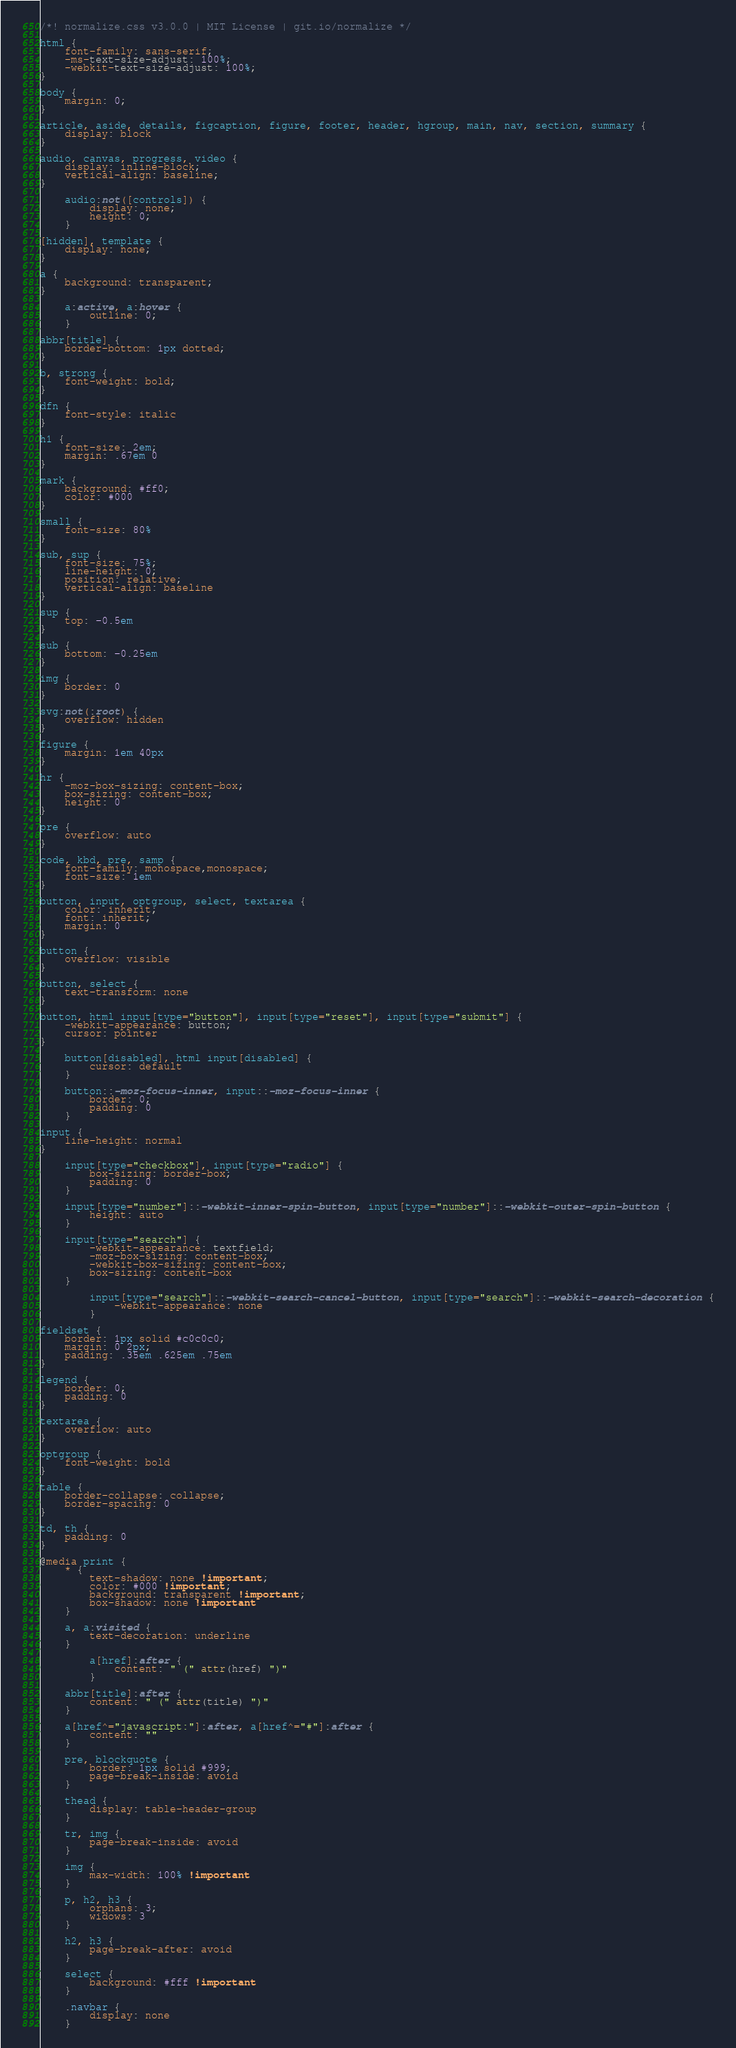Convert code to text. <code><loc_0><loc_0><loc_500><loc_500><_CSS_>/*! normalize.css v3.0.0 | MIT License | git.io/normalize */

html {
    font-family: sans-serif;
    -ms-text-size-adjust: 100%;
    -webkit-text-size-adjust: 100%;
}

body {
    margin: 0;
}

article, aside, details, figcaption, figure, footer, header, hgroup, main, nav, section, summary {
    display: block
}

audio, canvas, progress, video {
    display: inline-block;
    vertical-align: baseline;
}

    audio:not([controls]) {
        display: none;
        height: 0;
    }

[hidden], template {
    display: none;
}

a {
    background: transparent;
}

    a:active, a:hover {
        outline: 0;
    }

abbr[title] {
    border-bottom: 1px dotted;
}

b, strong {
    font-weight: bold;
}

dfn {
    font-style: italic
}

h1 {
    font-size: 2em;
    margin: .67em 0
}

mark {
    background: #ff0;
    color: #000
}

small {
    font-size: 80%
}

sub, sup {
    font-size: 75%;
    line-height: 0;
    position: relative;
    vertical-align: baseline
}

sup {
    top: -0.5em
}

sub {
    bottom: -0.25em
}

img {
    border: 0
}

svg:not(:root) {
    overflow: hidden
}

figure {
    margin: 1em 40px
}

hr {
    -moz-box-sizing: content-box;
    box-sizing: content-box;
    height: 0
}

pre {
    overflow: auto
}

code, kbd, pre, samp {
    font-family: monospace,monospace;
    font-size: 1em
}

button, input, optgroup, select, textarea {
    color: inherit;
    font: inherit;
    margin: 0
}

button {
    overflow: visible
}

button, select {
    text-transform: none
}

button, html input[type="button"], input[type="reset"], input[type="submit"] {
    -webkit-appearance: button;
    cursor: pointer
}

    button[disabled], html input[disabled] {
        cursor: default
    }

    button::-moz-focus-inner, input::-moz-focus-inner {
        border: 0;
        padding: 0
    }

input {
    line-height: normal
}

    input[type="checkbox"], input[type="radio"] {
        box-sizing: border-box;
        padding: 0
    }

    input[type="number"]::-webkit-inner-spin-button, input[type="number"]::-webkit-outer-spin-button {
        height: auto
    }

    input[type="search"] {
        -webkit-appearance: textfield;
        -moz-box-sizing: content-box;
        -webkit-box-sizing: content-box;
        box-sizing: content-box
    }

        input[type="search"]::-webkit-search-cancel-button, input[type="search"]::-webkit-search-decoration {
            -webkit-appearance: none
        }

fieldset {
    border: 1px solid #c0c0c0;
    margin: 0 2px;
    padding: .35em .625em .75em
}

legend {
    border: 0;
    padding: 0
}

textarea {
    overflow: auto
}

optgroup {
    font-weight: bold
}

table {
    border-collapse: collapse;
    border-spacing: 0
}

td, th {
    padding: 0
}

@media print {
    * {
        text-shadow: none !important;
        color: #000 !important;
        background: transparent !important;
        box-shadow: none !important
    }

    a, a:visited {
        text-decoration: underline
    }

        a[href]:after {
            content: " (" attr(href) ")"
        }

    abbr[title]:after {
        content: " (" attr(title) ")"
    }

    a[href^="javascript:"]:after, a[href^="#"]:after {
        content: ""
    }

    pre, blockquote {
        border: 1px solid #999;
        page-break-inside: avoid
    }

    thead {
        display: table-header-group
    }

    tr, img {
        page-break-inside: avoid
    }

    img {
        max-width: 100% !important
    }

    p, h2, h3 {
        orphans: 3;
        widows: 3
    }

    h2, h3 {
        page-break-after: avoid
    }

    select {
        background: #fff !important
    }

    .navbar {
        display: none
    }
</code> 